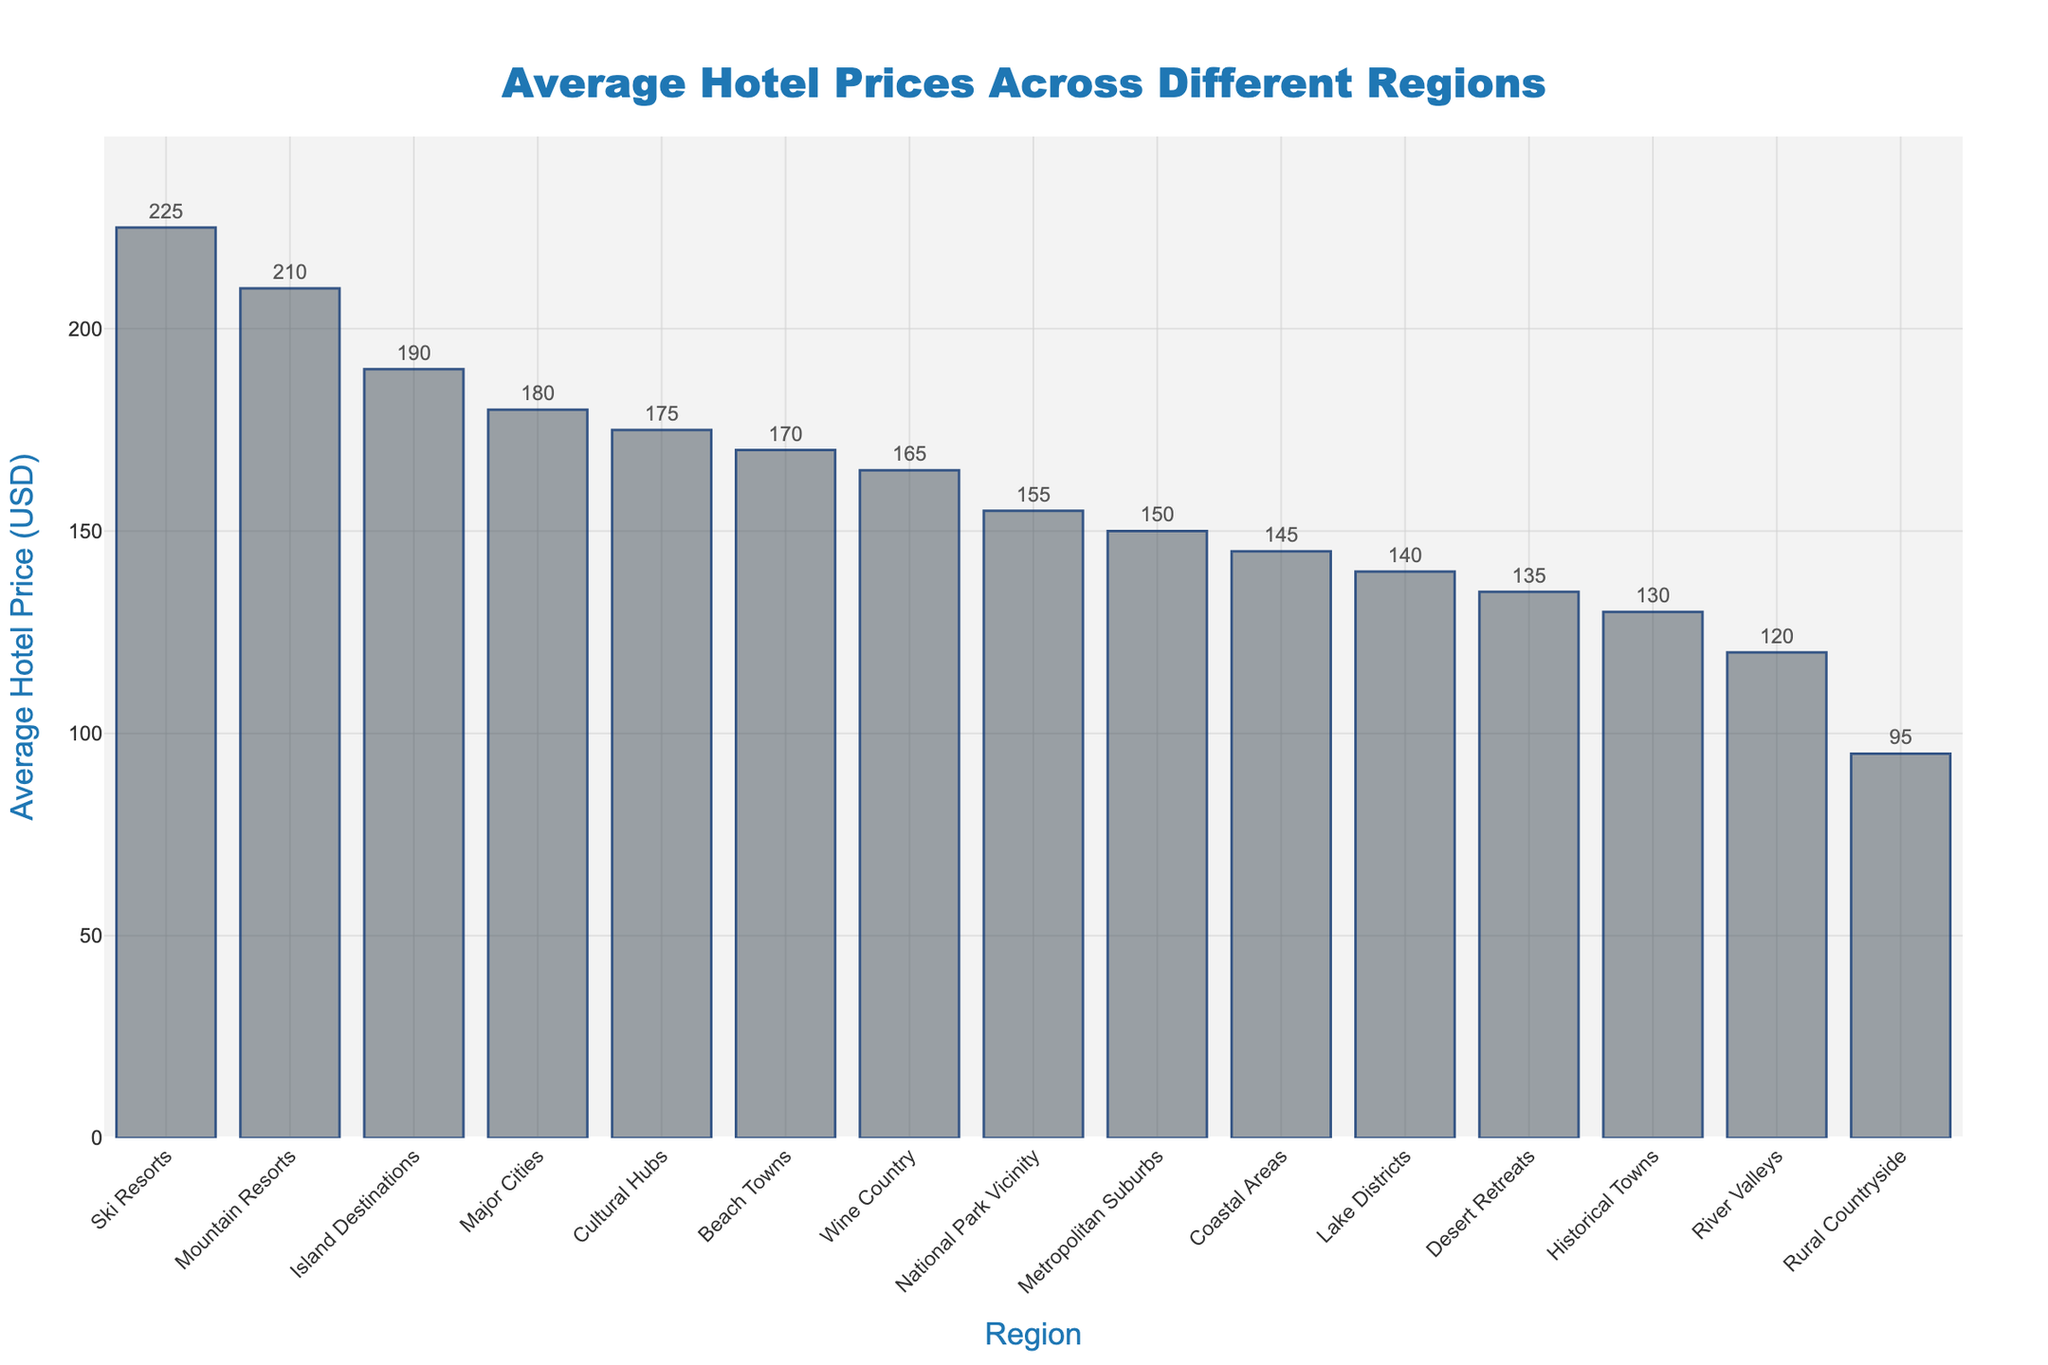Which region has the highest average hotel price? The region with the highest bar on the chart represents the highest average hotel price. This is for Ski Resorts.
Answer: Ski Resorts What is the difference in average hotel price between Mountain Resorts and Beach Towns? Locate Mountain Resorts and Beach Towns on the X-axis and check their corresponding Y values. Mountain Resorts is 210 USD and Beach Towns is 170 USD. The difference is 210 - 170 = 40 USD.
Answer: 40 USD Which region has the lowest average hotel price? The region with the shortest bar on the chart represents the lowest average hotel price. This is for Rural Countryside.
Answer: Rural Countryside How many regions have an average hotel price above 150 USD? Count the number of bars with a height representing a value above 150 on the Y-axis. These regions are Major Cities, Mountain Resorts, National Park Vicinity, Island Destinations, Wine Country, Cultural Hubs, Ski Resorts, and Beach Towns. There are 8 such regions.
Answer: 8 What is the average of the average hotel prices for Coastal Areas, Major Cities, and Mountain Resorts? Find the average hotel prices for Coastal Areas (145 USD), Major Cities (180 USD), and Mountain Resorts (210 USD). Calculate the average: (145 + 180 + 210) / 3 = 535 / 3 ≈ 178.33 USD.
Answer: 178.33 USD Which region has a higher average hotel price: Wine Country or River Valleys? Locate Wine Country and River Valleys on the X-axis and compare their corresponding Y values. Wine Country is 165 USD, and River Valleys is 120 USD. Wine Country has a higher average hotel price.
Answer: Wine Country What is the total average hotel price combined for Historical Towns and Desert Retreats? Find the average hotel prices for Historical Towns (130 USD) and Desert Retreats (135 USD). Sum them up: 130 + 135 = 265 USD.
Answer: 265 USD What is the median average hotel price among all the regions? To find the median, arrange all prices in ascending order and locate the middle value. Ordered prices: 95, 120, 130, 135, 140, 145, 150, 155, 165, 170, 175, 180, 190, 210, 225. The middle value (8th in a list of 15) is 155 USD.
Answer: 155 USD Is the average hotel price of Island Destinations greater than National Park Vicinity? Compare their respective bars on the chart. Island Destinations is 190 USD and National Park Vicinity is 155 USD. Yes, Island Destinations has a higher average hotel price.
Answer: Yes 